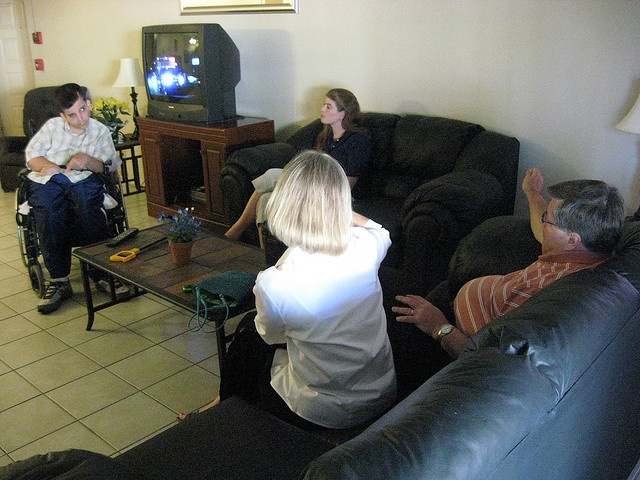Describe the objects in this image and their specific colors. I can see couch in darkgray, black, gray, and blue tones, people in darkgray, white, gray, and black tones, couch in darkgray, black, gray, darkgreen, and olive tones, people in darkgray, black, gray, maroon, and brown tones, and people in darkgray, black, lightgray, and navy tones in this image. 